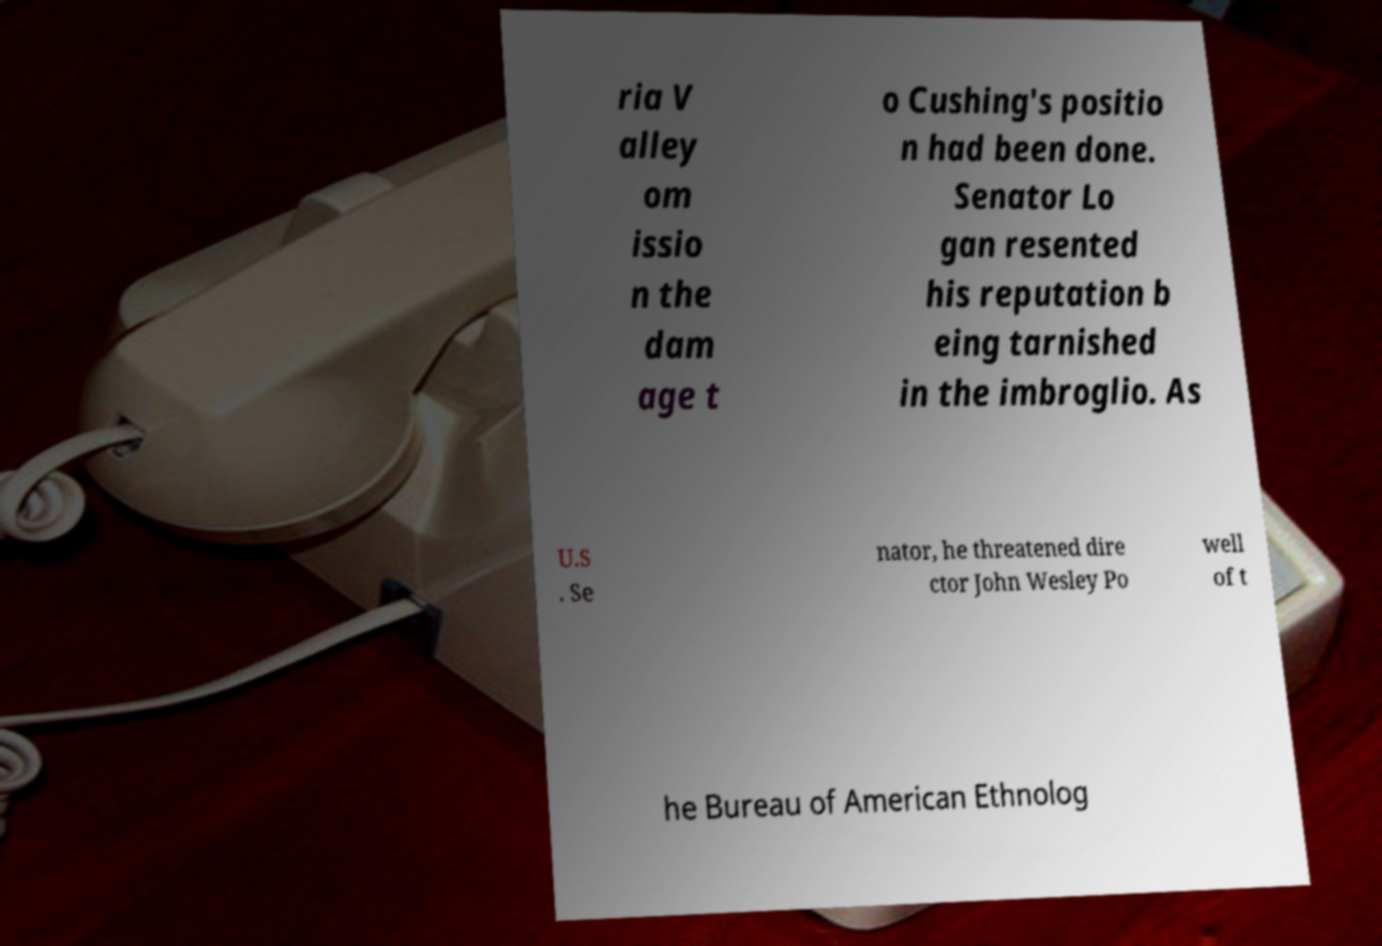For documentation purposes, I need the text within this image transcribed. Could you provide that? ria V alley om issio n the dam age t o Cushing's positio n had been done. Senator Lo gan resented his reputation b eing tarnished in the imbroglio. As U.S . Se nator, he threatened dire ctor John Wesley Po well of t he Bureau of American Ethnolog 